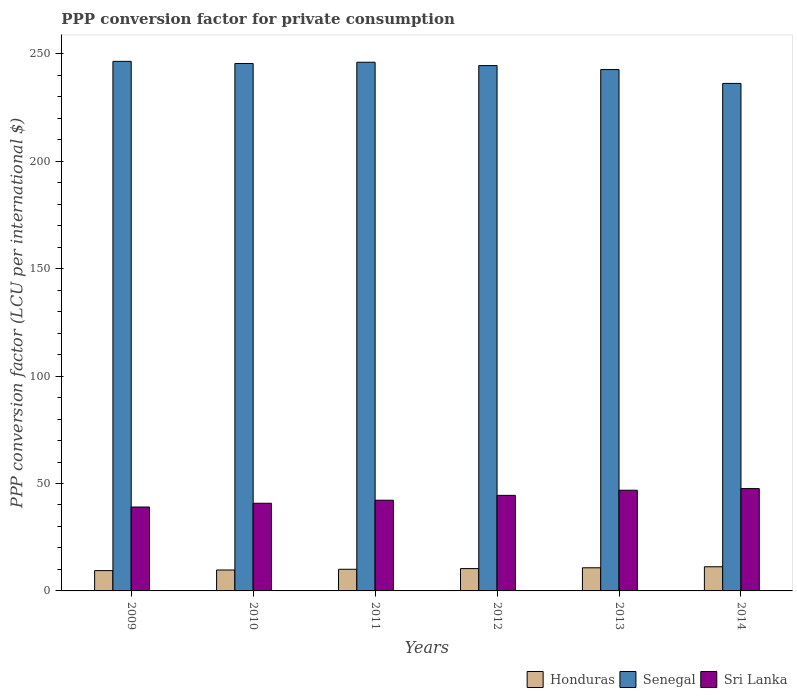How many different coloured bars are there?
Keep it short and to the point. 3. Are the number of bars per tick equal to the number of legend labels?
Provide a short and direct response. Yes. How many bars are there on the 3rd tick from the left?
Your answer should be compact. 3. In how many cases, is the number of bars for a given year not equal to the number of legend labels?
Provide a succinct answer. 0. What is the PPP conversion factor for private consumption in Honduras in 2012?
Provide a succinct answer. 10.39. Across all years, what is the maximum PPP conversion factor for private consumption in Honduras?
Your response must be concise. 11.25. Across all years, what is the minimum PPP conversion factor for private consumption in Sri Lanka?
Keep it short and to the point. 39.05. In which year was the PPP conversion factor for private consumption in Senegal maximum?
Give a very brief answer. 2009. In which year was the PPP conversion factor for private consumption in Honduras minimum?
Your answer should be compact. 2009. What is the total PPP conversion factor for private consumption in Senegal in the graph?
Make the answer very short. 1461.64. What is the difference between the PPP conversion factor for private consumption in Honduras in 2010 and that in 2014?
Offer a terse response. -1.51. What is the difference between the PPP conversion factor for private consumption in Senegal in 2012 and the PPP conversion factor for private consumption in Honduras in 2013?
Ensure brevity in your answer.  233.78. What is the average PPP conversion factor for private consumption in Sri Lanka per year?
Ensure brevity in your answer.  43.51. In the year 2009, what is the difference between the PPP conversion factor for private consumption in Sri Lanka and PPP conversion factor for private consumption in Honduras?
Offer a very short reply. 29.6. In how many years, is the PPP conversion factor for private consumption in Senegal greater than 90 LCU?
Your response must be concise. 6. What is the ratio of the PPP conversion factor for private consumption in Honduras in 2013 to that in 2014?
Keep it short and to the point. 0.96. What is the difference between the highest and the second highest PPP conversion factor for private consumption in Honduras?
Provide a short and direct response. 0.48. What is the difference between the highest and the lowest PPP conversion factor for private consumption in Sri Lanka?
Offer a very short reply. 8.58. In how many years, is the PPP conversion factor for private consumption in Senegal greater than the average PPP conversion factor for private consumption in Senegal taken over all years?
Provide a short and direct response. 4. What does the 1st bar from the left in 2009 represents?
Your response must be concise. Honduras. What does the 1st bar from the right in 2012 represents?
Provide a short and direct response. Sri Lanka. How many bars are there?
Your response must be concise. 18. How many years are there in the graph?
Give a very brief answer. 6. What is the difference between two consecutive major ticks on the Y-axis?
Ensure brevity in your answer.  50. Does the graph contain any zero values?
Your answer should be very brief. No. Where does the legend appear in the graph?
Your response must be concise. Bottom right. How many legend labels are there?
Make the answer very short. 3. What is the title of the graph?
Your answer should be compact. PPP conversion factor for private consumption. Does "Brazil" appear as one of the legend labels in the graph?
Your response must be concise. No. What is the label or title of the Y-axis?
Offer a very short reply. PPP conversion factor (LCU per international $). What is the PPP conversion factor (LCU per international $) of Honduras in 2009?
Your response must be concise. 9.46. What is the PPP conversion factor (LCU per international $) in Senegal in 2009?
Give a very brief answer. 246.52. What is the PPP conversion factor (LCU per international $) in Sri Lanka in 2009?
Ensure brevity in your answer.  39.05. What is the PPP conversion factor (LCU per international $) in Honduras in 2010?
Provide a short and direct response. 9.74. What is the PPP conversion factor (LCU per international $) of Senegal in 2010?
Make the answer very short. 245.52. What is the PPP conversion factor (LCU per international $) in Sri Lanka in 2010?
Offer a terse response. 40.81. What is the PPP conversion factor (LCU per international $) in Honduras in 2011?
Ensure brevity in your answer.  10.08. What is the PPP conversion factor (LCU per international $) in Senegal in 2011?
Provide a short and direct response. 246.11. What is the PPP conversion factor (LCU per international $) of Sri Lanka in 2011?
Give a very brief answer. 42.22. What is the PPP conversion factor (LCU per international $) in Honduras in 2012?
Offer a very short reply. 10.39. What is the PPP conversion factor (LCU per international $) of Senegal in 2012?
Ensure brevity in your answer.  244.55. What is the PPP conversion factor (LCU per international $) of Sri Lanka in 2012?
Give a very brief answer. 44.48. What is the PPP conversion factor (LCU per international $) in Honduras in 2013?
Ensure brevity in your answer.  10.77. What is the PPP conversion factor (LCU per international $) in Senegal in 2013?
Make the answer very short. 242.7. What is the PPP conversion factor (LCU per international $) of Sri Lanka in 2013?
Provide a succinct answer. 46.87. What is the PPP conversion factor (LCU per international $) in Honduras in 2014?
Offer a very short reply. 11.25. What is the PPP conversion factor (LCU per international $) in Senegal in 2014?
Provide a short and direct response. 236.25. What is the PPP conversion factor (LCU per international $) of Sri Lanka in 2014?
Make the answer very short. 47.63. Across all years, what is the maximum PPP conversion factor (LCU per international $) in Honduras?
Your answer should be very brief. 11.25. Across all years, what is the maximum PPP conversion factor (LCU per international $) of Senegal?
Provide a short and direct response. 246.52. Across all years, what is the maximum PPP conversion factor (LCU per international $) of Sri Lanka?
Provide a short and direct response. 47.63. Across all years, what is the minimum PPP conversion factor (LCU per international $) of Honduras?
Keep it short and to the point. 9.46. Across all years, what is the minimum PPP conversion factor (LCU per international $) in Senegal?
Your answer should be very brief. 236.25. Across all years, what is the minimum PPP conversion factor (LCU per international $) in Sri Lanka?
Give a very brief answer. 39.05. What is the total PPP conversion factor (LCU per international $) of Honduras in the graph?
Ensure brevity in your answer.  61.68. What is the total PPP conversion factor (LCU per international $) in Senegal in the graph?
Ensure brevity in your answer.  1461.64. What is the total PPP conversion factor (LCU per international $) of Sri Lanka in the graph?
Your answer should be very brief. 261.07. What is the difference between the PPP conversion factor (LCU per international $) in Honduras in 2009 and that in 2010?
Offer a terse response. -0.28. What is the difference between the PPP conversion factor (LCU per international $) in Senegal in 2009 and that in 2010?
Make the answer very short. 1. What is the difference between the PPP conversion factor (LCU per international $) in Sri Lanka in 2009 and that in 2010?
Your answer should be very brief. -1.76. What is the difference between the PPP conversion factor (LCU per international $) of Honduras in 2009 and that in 2011?
Provide a short and direct response. -0.63. What is the difference between the PPP conversion factor (LCU per international $) of Senegal in 2009 and that in 2011?
Your answer should be very brief. 0.41. What is the difference between the PPP conversion factor (LCU per international $) in Sri Lanka in 2009 and that in 2011?
Give a very brief answer. -3.17. What is the difference between the PPP conversion factor (LCU per international $) in Honduras in 2009 and that in 2012?
Offer a terse response. -0.93. What is the difference between the PPP conversion factor (LCU per international $) of Senegal in 2009 and that in 2012?
Provide a short and direct response. 1.97. What is the difference between the PPP conversion factor (LCU per international $) of Sri Lanka in 2009 and that in 2012?
Your answer should be compact. -5.43. What is the difference between the PPP conversion factor (LCU per international $) in Honduras in 2009 and that in 2013?
Your answer should be very brief. -1.31. What is the difference between the PPP conversion factor (LCU per international $) in Senegal in 2009 and that in 2013?
Your response must be concise. 3.82. What is the difference between the PPP conversion factor (LCU per international $) of Sri Lanka in 2009 and that in 2013?
Your answer should be very brief. -7.82. What is the difference between the PPP conversion factor (LCU per international $) in Honduras in 2009 and that in 2014?
Your response must be concise. -1.79. What is the difference between the PPP conversion factor (LCU per international $) in Senegal in 2009 and that in 2014?
Your answer should be compact. 10.27. What is the difference between the PPP conversion factor (LCU per international $) in Sri Lanka in 2009 and that in 2014?
Your answer should be compact. -8.58. What is the difference between the PPP conversion factor (LCU per international $) in Honduras in 2010 and that in 2011?
Your answer should be very brief. -0.34. What is the difference between the PPP conversion factor (LCU per international $) of Senegal in 2010 and that in 2011?
Give a very brief answer. -0.59. What is the difference between the PPP conversion factor (LCU per international $) in Sri Lanka in 2010 and that in 2011?
Offer a terse response. -1.41. What is the difference between the PPP conversion factor (LCU per international $) in Honduras in 2010 and that in 2012?
Provide a short and direct response. -0.65. What is the difference between the PPP conversion factor (LCU per international $) of Senegal in 2010 and that in 2012?
Ensure brevity in your answer.  0.98. What is the difference between the PPP conversion factor (LCU per international $) of Sri Lanka in 2010 and that in 2012?
Your response must be concise. -3.67. What is the difference between the PPP conversion factor (LCU per international $) in Honduras in 2010 and that in 2013?
Give a very brief answer. -1.03. What is the difference between the PPP conversion factor (LCU per international $) in Senegal in 2010 and that in 2013?
Provide a succinct answer. 2.82. What is the difference between the PPP conversion factor (LCU per international $) in Sri Lanka in 2010 and that in 2013?
Your answer should be very brief. -6.06. What is the difference between the PPP conversion factor (LCU per international $) of Honduras in 2010 and that in 2014?
Give a very brief answer. -1.51. What is the difference between the PPP conversion factor (LCU per international $) of Senegal in 2010 and that in 2014?
Give a very brief answer. 9.27. What is the difference between the PPP conversion factor (LCU per international $) of Sri Lanka in 2010 and that in 2014?
Your response must be concise. -6.82. What is the difference between the PPP conversion factor (LCU per international $) in Honduras in 2011 and that in 2012?
Provide a short and direct response. -0.31. What is the difference between the PPP conversion factor (LCU per international $) in Senegal in 2011 and that in 2012?
Your answer should be very brief. 1.56. What is the difference between the PPP conversion factor (LCU per international $) in Sri Lanka in 2011 and that in 2012?
Make the answer very short. -2.26. What is the difference between the PPP conversion factor (LCU per international $) in Honduras in 2011 and that in 2013?
Provide a short and direct response. -0.69. What is the difference between the PPP conversion factor (LCU per international $) in Senegal in 2011 and that in 2013?
Keep it short and to the point. 3.41. What is the difference between the PPP conversion factor (LCU per international $) of Sri Lanka in 2011 and that in 2013?
Provide a succinct answer. -4.65. What is the difference between the PPP conversion factor (LCU per international $) in Honduras in 2011 and that in 2014?
Keep it short and to the point. -1.16. What is the difference between the PPP conversion factor (LCU per international $) of Senegal in 2011 and that in 2014?
Offer a terse response. 9.86. What is the difference between the PPP conversion factor (LCU per international $) of Sri Lanka in 2011 and that in 2014?
Your answer should be compact. -5.42. What is the difference between the PPP conversion factor (LCU per international $) in Honduras in 2012 and that in 2013?
Offer a terse response. -0.38. What is the difference between the PPP conversion factor (LCU per international $) in Senegal in 2012 and that in 2013?
Keep it short and to the point. 1.85. What is the difference between the PPP conversion factor (LCU per international $) in Sri Lanka in 2012 and that in 2013?
Offer a terse response. -2.39. What is the difference between the PPP conversion factor (LCU per international $) of Honduras in 2012 and that in 2014?
Ensure brevity in your answer.  -0.86. What is the difference between the PPP conversion factor (LCU per international $) of Senegal in 2012 and that in 2014?
Make the answer very short. 8.3. What is the difference between the PPP conversion factor (LCU per international $) in Sri Lanka in 2012 and that in 2014?
Ensure brevity in your answer.  -3.15. What is the difference between the PPP conversion factor (LCU per international $) in Honduras in 2013 and that in 2014?
Your answer should be very brief. -0.48. What is the difference between the PPP conversion factor (LCU per international $) in Senegal in 2013 and that in 2014?
Offer a terse response. 6.45. What is the difference between the PPP conversion factor (LCU per international $) in Sri Lanka in 2013 and that in 2014?
Make the answer very short. -0.76. What is the difference between the PPP conversion factor (LCU per international $) in Honduras in 2009 and the PPP conversion factor (LCU per international $) in Senegal in 2010?
Your response must be concise. -236.07. What is the difference between the PPP conversion factor (LCU per international $) in Honduras in 2009 and the PPP conversion factor (LCU per international $) in Sri Lanka in 2010?
Your response must be concise. -31.36. What is the difference between the PPP conversion factor (LCU per international $) of Senegal in 2009 and the PPP conversion factor (LCU per international $) of Sri Lanka in 2010?
Give a very brief answer. 205.71. What is the difference between the PPP conversion factor (LCU per international $) in Honduras in 2009 and the PPP conversion factor (LCU per international $) in Senegal in 2011?
Your response must be concise. -236.65. What is the difference between the PPP conversion factor (LCU per international $) of Honduras in 2009 and the PPP conversion factor (LCU per international $) of Sri Lanka in 2011?
Your answer should be very brief. -32.76. What is the difference between the PPP conversion factor (LCU per international $) of Senegal in 2009 and the PPP conversion factor (LCU per international $) of Sri Lanka in 2011?
Your response must be concise. 204.3. What is the difference between the PPP conversion factor (LCU per international $) of Honduras in 2009 and the PPP conversion factor (LCU per international $) of Senegal in 2012?
Your answer should be very brief. -235.09. What is the difference between the PPP conversion factor (LCU per international $) of Honduras in 2009 and the PPP conversion factor (LCU per international $) of Sri Lanka in 2012?
Provide a short and direct response. -35.03. What is the difference between the PPP conversion factor (LCU per international $) of Senegal in 2009 and the PPP conversion factor (LCU per international $) of Sri Lanka in 2012?
Make the answer very short. 202.04. What is the difference between the PPP conversion factor (LCU per international $) in Honduras in 2009 and the PPP conversion factor (LCU per international $) in Senegal in 2013?
Your answer should be compact. -233.24. What is the difference between the PPP conversion factor (LCU per international $) in Honduras in 2009 and the PPP conversion factor (LCU per international $) in Sri Lanka in 2013?
Make the answer very short. -37.42. What is the difference between the PPP conversion factor (LCU per international $) in Senegal in 2009 and the PPP conversion factor (LCU per international $) in Sri Lanka in 2013?
Your answer should be compact. 199.65. What is the difference between the PPP conversion factor (LCU per international $) in Honduras in 2009 and the PPP conversion factor (LCU per international $) in Senegal in 2014?
Provide a succinct answer. -226.79. What is the difference between the PPP conversion factor (LCU per international $) of Honduras in 2009 and the PPP conversion factor (LCU per international $) of Sri Lanka in 2014?
Your response must be concise. -38.18. What is the difference between the PPP conversion factor (LCU per international $) of Senegal in 2009 and the PPP conversion factor (LCU per international $) of Sri Lanka in 2014?
Make the answer very short. 198.88. What is the difference between the PPP conversion factor (LCU per international $) of Honduras in 2010 and the PPP conversion factor (LCU per international $) of Senegal in 2011?
Provide a short and direct response. -236.37. What is the difference between the PPP conversion factor (LCU per international $) of Honduras in 2010 and the PPP conversion factor (LCU per international $) of Sri Lanka in 2011?
Your answer should be compact. -32.48. What is the difference between the PPP conversion factor (LCU per international $) of Senegal in 2010 and the PPP conversion factor (LCU per international $) of Sri Lanka in 2011?
Your answer should be very brief. 203.3. What is the difference between the PPP conversion factor (LCU per international $) of Honduras in 2010 and the PPP conversion factor (LCU per international $) of Senegal in 2012?
Give a very brief answer. -234.81. What is the difference between the PPP conversion factor (LCU per international $) of Honduras in 2010 and the PPP conversion factor (LCU per international $) of Sri Lanka in 2012?
Make the answer very short. -34.74. What is the difference between the PPP conversion factor (LCU per international $) of Senegal in 2010 and the PPP conversion factor (LCU per international $) of Sri Lanka in 2012?
Provide a short and direct response. 201.04. What is the difference between the PPP conversion factor (LCU per international $) of Honduras in 2010 and the PPP conversion factor (LCU per international $) of Senegal in 2013?
Keep it short and to the point. -232.96. What is the difference between the PPP conversion factor (LCU per international $) in Honduras in 2010 and the PPP conversion factor (LCU per international $) in Sri Lanka in 2013?
Keep it short and to the point. -37.13. What is the difference between the PPP conversion factor (LCU per international $) of Senegal in 2010 and the PPP conversion factor (LCU per international $) of Sri Lanka in 2013?
Offer a terse response. 198.65. What is the difference between the PPP conversion factor (LCU per international $) in Honduras in 2010 and the PPP conversion factor (LCU per international $) in Senegal in 2014?
Give a very brief answer. -226.51. What is the difference between the PPP conversion factor (LCU per international $) in Honduras in 2010 and the PPP conversion factor (LCU per international $) in Sri Lanka in 2014?
Keep it short and to the point. -37.89. What is the difference between the PPP conversion factor (LCU per international $) in Senegal in 2010 and the PPP conversion factor (LCU per international $) in Sri Lanka in 2014?
Offer a terse response. 197.89. What is the difference between the PPP conversion factor (LCU per international $) in Honduras in 2011 and the PPP conversion factor (LCU per international $) in Senegal in 2012?
Give a very brief answer. -234.46. What is the difference between the PPP conversion factor (LCU per international $) of Honduras in 2011 and the PPP conversion factor (LCU per international $) of Sri Lanka in 2012?
Provide a succinct answer. -34.4. What is the difference between the PPP conversion factor (LCU per international $) of Senegal in 2011 and the PPP conversion factor (LCU per international $) of Sri Lanka in 2012?
Offer a terse response. 201.62. What is the difference between the PPP conversion factor (LCU per international $) of Honduras in 2011 and the PPP conversion factor (LCU per international $) of Senegal in 2013?
Offer a very short reply. -232.62. What is the difference between the PPP conversion factor (LCU per international $) in Honduras in 2011 and the PPP conversion factor (LCU per international $) in Sri Lanka in 2013?
Ensure brevity in your answer.  -36.79. What is the difference between the PPP conversion factor (LCU per international $) of Senegal in 2011 and the PPP conversion factor (LCU per international $) of Sri Lanka in 2013?
Keep it short and to the point. 199.24. What is the difference between the PPP conversion factor (LCU per international $) in Honduras in 2011 and the PPP conversion factor (LCU per international $) in Senegal in 2014?
Provide a short and direct response. -226.17. What is the difference between the PPP conversion factor (LCU per international $) in Honduras in 2011 and the PPP conversion factor (LCU per international $) in Sri Lanka in 2014?
Ensure brevity in your answer.  -37.55. What is the difference between the PPP conversion factor (LCU per international $) of Senegal in 2011 and the PPP conversion factor (LCU per international $) of Sri Lanka in 2014?
Your response must be concise. 198.47. What is the difference between the PPP conversion factor (LCU per international $) in Honduras in 2012 and the PPP conversion factor (LCU per international $) in Senegal in 2013?
Ensure brevity in your answer.  -232.31. What is the difference between the PPP conversion factor (LCU per international $) of Honduras in 2012 and the PPP conversion factor (LCU per international $) of Sri Lanka in 2013?
Keep it short and to the point. -36.48. What is the difference between the PPP conversion factor (LCU per international $) of Senegal in 2012 and the PPP conversion factor (LCU per international $) of Sri Lanka in 2013?
Give a very brief answer. 197.67. What is the difference between the PPP conversion factor (LCU per international $) in Honduras in 2012 and the PPP conversion factor (LCU per international $) in Senegal in 2014?
Your answer should be compact. -225.86. What is the difference between the PPP conversion factor (LCU per international $) in Honduras in 2012 and the PPP conversion factor (LCU per international $) in Sri Lanka in 2014?
Offer a very short reply. -37.25. What is the difference between the PPP conversion factor (LCU per international $) of Senegal in 2012 and the PPP conversion factor (LCU per international $) of Sri Lanka in 2014?
Offer a terse response. 196.91. What is the difference between the PPP conversion factor (LCU per international $) of Honduras in 2013 and the PPP conversion factor (LCU per international $) of Senegal in 2014?
Ensure brevity in your answer.  -225.48. What is the difference between the PPP conversion factor (LCU per international $) in Honduras in 2013 and the PPP conversion factor (LCU per international $) in Sri Lanka in 2014?
Offer a terse response. -36.87. What is the difference between the PPP conversion factor (LCU per international $) of Senegal in 2013 and the PPP conversion factor (LCU per international $) of Sri Lanka in 2014?
Give a very brief answer. 195.06. What is the average PPP conversion factor (LCU per international $) in Honduras per year?
Provide a succinct answer. 10.28. What is the average PPP conversion factor (LCU per international $) of Senegal per year?
Your answer should be very brief. 243.61. What is the average PPP conversion factor (LCU per international $) in Sri Lanka per year?
Offer a terse response. 43.51. In the year 2009, what is the difference between the PPP conversion factor (LCU per international $) in Honduras and PPP conversion factor (LCU per international $) in Senegal?
Offer a terse response. -237.06. In the year 2009, what is the difference between the PPP conversion factor (LCU per international $) in Honduras and PPP conversion factor (LCU per international $) in Sri Lanka?
Make the answer very short. -29.6. In the year 2009, what is the difference between the PPP conversion factor (LCU per international $) in Senegal and PPP conversion factor (LCU per international $) in Sri Lanka?
Give a very brief answer. 207.47. In the year 2010, what is the difference between the PPP conversion factor (LCU per international $) in Honduras and PPP conversion factor (LCU per international $) in Senegal?
Keep it short and to the point. -235.78. In the year 2010, what is the difference between the PPP conversion factor (LCU per international $) in Honduras and PPP conversion factor (LCU per international $) in Sri Lanka?
Provide a succinct answer. -31.07. In the year 2010, what is the difference between the PPP conversion factor (LCU per international $) in Senegal and PPP conversion factor (LCU per international $) in Sri Lanka?
Provide a short and direct response. 204.71. In the year 2011, what is the difference between the PPP conversion factor (LCU per international $) in Honduras and PPP conversion factor (LCU per international $) in Senegal?
Your answer should be compact. -236.03. In the year 2011, what is the difference between the PPP conversion factor (LCU per international $) in Honduras and PPP conversion factor (LCU per international $) in Sri Lanka?
Offer a terse response. -32.14. In the year 2011, what is the difference between the PPP conversion factor (LCU per international $) in Senegal and PPP conversion factor (LCU per international $) in Sri Lanka?
Make the answer very short. 203.89. In the year 2012, what is the difference between the PPP conversion factor (LCU per international $) of Honduras and PPP conversion factor (LCU per international $) of Senegal?
Provide a succinct answer. -234.16. In the year 2012, what is the difference between the PPP conversion factor (LCU per international $) of Honduras and PPP conversion factor (LCU per international $) of Sri Lanka?
Your answer should be compact. -34.09. In the year 2012, what is the difference between the PPP conversion factor (LCU per international $) in Senegal and PPP conversion factor (LCU per international $) in Sri Lanka?
Ensure brevity in your answer.  200.06. In the year 2013, what is the difference between the PPP conversion factor (LCU per international $) of Honduras and PPP conversion factor (LCU per international $) of Senegal?
Your answer should be compact. -231.93. In the year 2013, what is the difference between the PPP conversion factor (LCU per international $) of Honduras and PPP conversion factor (LCU per international $) of Sri Lanka?
Provide a short and direct response. -36.1. In the year 2013, what is the difference between the PPP conversion factor (LCU per international $) of Senegal and PPP conversion factor (LCU per international $) of Sri Lanka?
Offer a very short reply. 195.83. In the year 2014, what is the difference between the PPP conversion factor (LCU per international $) of Honduras and PPP conversion factor (LCU per international $) of Senegal?
Provide a short and direct response. -225. In the year 2014, what is the difference between the PPP conversion factor (LCU per international $) of Honduras and PPP conversion factor (LCU per international $) of Sri Lanka?
Make the answer very short. -36.39. In the year 2014, what is the difference between the PPP conversion factor (LCU per international $) of Senegal and PPP conversion factor (LCU per international $) of Sri Lanka?
Your response must be concise. 188.61. What is the ratio of the PPP conversion factor (LCU per international $) of Honduras in 2009 to that in 2010?
Your response must be concise. 0.97. What is the ratio of the PPP conversion factor (LCU per international $) in Senegal in 2009 to that in 2010?
Offer a terse response. 1. What is the ratio of the PPP conversion factor (LCU per international $) of Sri Lanka in 2009 to that in 2010?
Your answer should be very brief. 0.96. What is the ratio of the PPP conversion factor (LCU per international $) of Honduras in 2009 to that in 2011?
Provide a short and direct response. 0.94. What is the ratio of the PPP conversion factor (LCU per international $) of Senegal in 2009 to that in 2011?
Keep it short and to the point. 1. What is the ratio of the PPP conversion factor (LCU per international $) in Sri Lanka in 2009 to that in 2011?
Keep it short and to the point. 0.93. What is the ratio of the PPP conversion factor (LCU per international $) in Honduras in 2009 to that in 2012?
Your response must be concise. 0.91. What is the ratio of the PPP conversion factor (LCU per international $) of Sri Lanka in 2009 to that in 2012?
Provide a succinct answer. 0.88. What is the ratio of the PPP conversion factor (LCU per international $) of Honduras in 2009 to that in 2013?
Ensure brevity in your answer.  0.88. What is the ratio of the PPP conversion factor (LCU per international $) of Senegal in 2009 to that in 2013?
Ensure brevity in your answer.  1.02. What is the ratio of the PPP conversion factor (LCU per international $) of Sri Lanka in 2009 to that in 2013?
Provide a succinct answer. 0.83. What is the ratio of the PPP conversion factor (LCU per international $) of Honduras in 2009 to that in 2014?
Ensure brevity in your answer.  0.84. What is the ratio of the PPP conversion factor (LCU per international $) in Senegal in 2009 to that in 2014?
Provide a short and direct response. 1.04. What is the ratio of the PPP conversion factor (LCU per international $) of Sri Lanka in 2009 to that in 2014?
Provide a succinct answer. 0.82. What is the ratio of the PPP conversion factor (LCU per international $) in Honduras in 2010 to that in 2011?
Give a very brief answer. 0.97. What is the ratio of the PPP conversion factor (LCU per international $) of Sri Lanka in 2010 to that in 2011?
Provide a succinct answer. 0.97. What is the ratio of the PPP conversion factor (LCU per international $) of Honduras in 2010 to that in 2012?
Offer a very short reply. 0.94. What is the ratio of the PPP conversion factor (LCU per international $) of Senegal in 2010 to that in 2012?
Keep it short and to the point. 1. What is the ratio of the PPP conversion factor (LCU per international $) of Sri Lanka in 2010 to that in 2012?
Your answer should be very brief. 0.92. What is the ratio of the PPP conversion factor (LCU per international $) of Honduras in 2010 to that in 2013?
Give a very brief answer. 0.9. What is the ratio of the PPP conversion factor (LCU per international $) in Senegal in 2010 to that in 2013?
Keep it short and to the point. 1.01. What is the ratio of the PPP conversion factor (LCU per international $) in Sri Lanka in 2010 to that in 2013?
Your response must be concise. 0.87. What is the ratio of the PPP conversion factor (LCU per international $) of Honduras in 2010 to that in 2014?
Your answer should be compact. 0.87. What is the ratio of the PPP conversion factor (LCU per international $) of Senegal in 2010 to that in 2014?
Provide a short and direct response. 1.04. What is the ratio of the PPP conversion factor (LCU per international $) in Sri Lanka in 2010 to that in 2014?
Offer a terse response. 0.86. What is the ratio of the PPP conversion factor (LCU per international $) in Honduras in 2011 to that in 2012?
Your answer should be very brief. 0.97. What is the ratio of the PPP conversion factor (LCU per international $) of Senegal in 2011 to that in 2012?
Provide a succinct answer. 1.01. What is the ratio of the PPP conversion factor (LCU per international $) in Sri Lanka in 2011 to that in 2012?
Keep it short and to the point. 0.95. What is the ratio of the PPP conversion factor (LCU per international $) in Honduras in 2011 to that in 2013?
Your response must be concise. 0.94. What is the ratio of the PPP conversion factor (LCU per international $) of Senegal in 2011 to that in 2013?
Ensure brevity in your answer.  1.01. What is the ratio of the PPP conversion factor (LCU per international $) of Sri Lanka in 2011 to that in 2013?
Give a very brief answer. 0.9. What is the ratio of the PPP conversion factor (LCU per international $) in Honduras in 2011 to that in 2014?
Offer a very short reply. 0.9. What is the ratio of the PPP conversion factor (LCU per international $) of Senegal in 2011 to that in 2014?
Keep it short and to the point. 1.04. What is the ratio of the PPP conversion factor (LCU per international $) of Sri Lanka in 2011 to that in 2014?
Offer a very short reply. 0.89. What is the ratio of the PPP conversion factor (LCU per international $) in Honduras in 2012 to that in 2013?
Ensure brevity in your answer.  0.96. What is the ratio of the PPP conversion factor (LCU per international $) of Senegal in 2012 to that in 2013?
Your answer should be compact. 1.01. What is the ratio of the PPP conversion factor (LCU per international $) of Sri Lanka in 2012 to that in 2013?
Your response must be concise. 0.95. What is the ratio of the PPP conversion factor (LCU per international $) in Honduras in 2012 to that in 2014?
Offer a terse response. 0.92. What is the ratio of the PPP conversion factor (LCU per international $) of Senegal in 2012 to that in 2014?
Offer a very short reply. 1.04. What is the ratio of the PPP conversion factor (LCU per international $) of Sri Lanka in 2012 to that in 2014?
Offer a very short reply. 0.93. What is the ratio of the PPP conversion factor (LCU per international $) of Honduras in 2013 to that in 2014?
Offer a very short reply. 0.96. What is the ratio of the PPP conversion factor (LCU per international $) in Senegal in 2013 to that in 2014?
Offer a very short reply. 1.03. What is the difference between the highest and the second highest PPP conversion factor (LCU per international $) in Honduras?
Provide a short and direct response. 0.48. What is the difference between the highest and the second highest PPP conversion factor (LCU per international $) in Senegal?
Provide a succinct answer. 0.41. What is the difference between the highest and the second highest PPP conversion factor (LCU per international $) in Sri Lanka?
Make the answer very short. 0.76. What is the difference between the highest and the lowest PPP conversion factor (LCU per international $) in Honduras?
Ensure brevity in your answer.  1.79. What is the difference between the highest and the lowest PPP conversion factor (LCU per international $) in Senegal?
Offer a very short reply. 10.27. What is the difference between the highest and the lowest PPP conversion factor (LCU per international $) of Sri Lanka?
Make the answer very short. 8.58. 